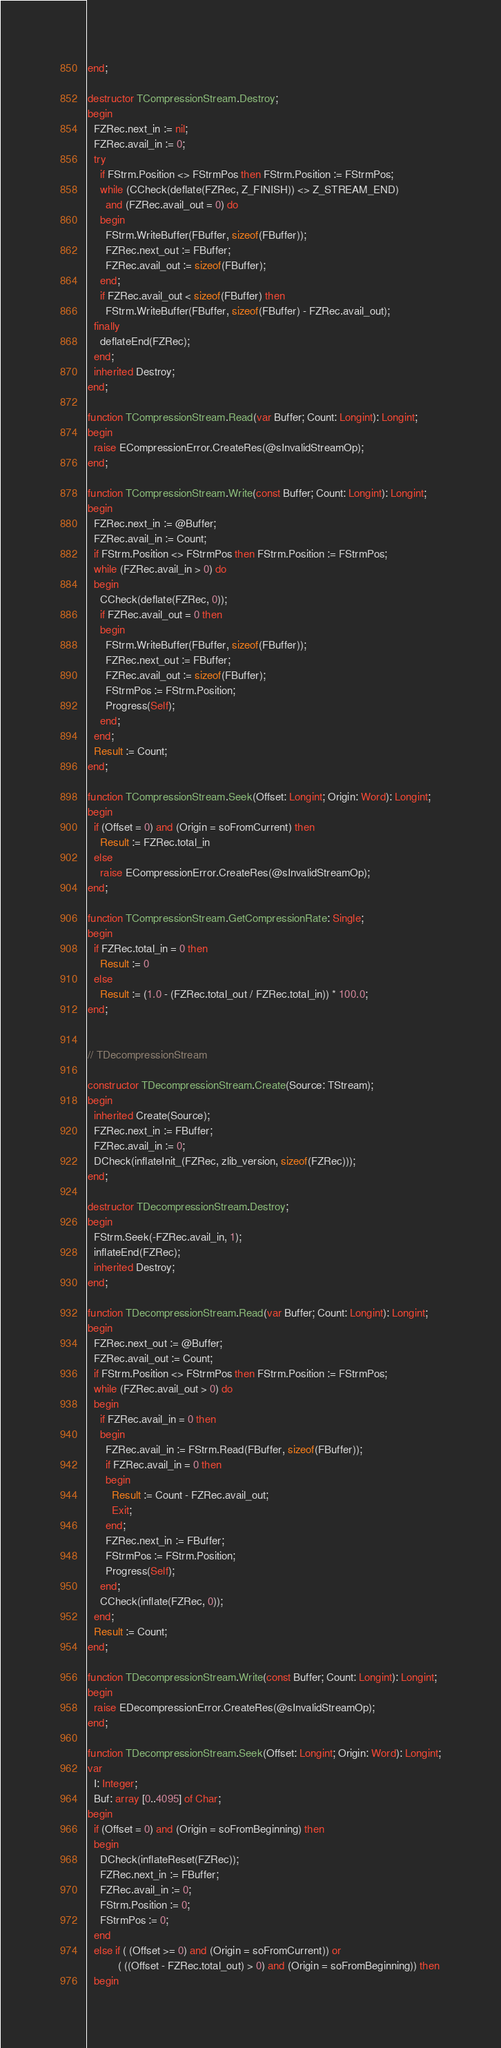Convert code to text. <code><loc_0><loc_0><loc_500><loc_500><_Pascal_>end;

destructor TCompressionStream.Destroy;
begin
  FZRec.next_in := nil;
  FZRec.avail_in := 0;
  try
    if FStrm.Position <> FStrmPos then FStrm.Position := FStrmPos;
    while (CCheck(deflate(FZRec, Z_FINISH)) <> Z_STREAM_END)
      and (FZRec.avail_out = 0) do
    begin
      FStrm.WriteBuffer(FBuffer, sizeof(FBuffer));
      FZRec.next_out := FBuffer;
      FZRec.avail_out := sizeof(FBuffer);
    end;
    if FZRec.avail_out < sizeof(FBuffer) then
      FStrm.WriteBuffer(FBuffer, sizeof(FBuffer) - FZRec.avail_out);
  finally
    deflateEnd(FZRec);
  end;
  inherited Destroy;
end;

function TCompressionStream.Read(var Buffer; Count: Longint): Longint;
begin
  raise ECompressionError.CreateRes(@sInvalidStreamOp);
end;

function TCompressionStream.Write(const Buffer; Count: Longint): Longint;
begin
  FZRec.next_in := @Buffer;
  FZRec.avail_in := Count;
  if FStrm.Position <> FStrmPos then FStrm.Position := FStrmPos;
  while (FZRec.avail_in > 0) do
  begin
    CCheck(deflate(FZRec, 0));
    if FZRec.avail_out = 0 then
    begin
      FStrm.WriteBuffer(FBuffer, sizeof(FBuffer));
      FZRec.next_out := FBuffer;
      FZRec.avail_out := sizeof(FBuffer);
      FStrmPos := FStrm.Position;
      Progress(Self);
    end;
  end;
  Result := Count;
end;

function TCompressionStream.Seek(Offset: Longint; Origin: Word): Longint;
begin
  if (Offset = 0) and (Origin = soFromCurrent) then
    Result := FZRec.total_in
  else
    raise ECompressionError.CreateRes(@sInvalidStreamOp);
end;

function TCompressionStream.GetCompressionRate: Single;
begin
  if FZRec.total_in = 0 then
    Result := 0
  else
    Result := (1.0 - (FZRec.total_out / FZRec.total_in)) * 100.0;
end;


// TDecompressionStream

constructor TDecompressionStream.Create(Source: TStream);
begin
  inherited Create(Source);
  FZRec.next_in := FBuffer;
  FZRec.avail_in := 0;
  DCheck(inflateInit_(FZRec, zlib_version, sizeof(FZRec)));
end;

destructor TDecompressionStream.Destroy;
begin
  FStrm.Seek(-FZRec.avail_in, 1);
  inflateEnd(FZRec);
  inherited Destroy;
end;

function TDecompressionStream.Read(var Buffer; Count: Longint): Longint;
begin
  FZRec.next_out := @Buffer;
  FZRec.avail_out := Count;
  if FStrm.Position <> FStrmPos then FStrm.Position := FStrmPos;
  while (FZRec.avail_out > 0) do
  begin
    if FZRec.avail_in = 0 then
    begin
      FZRec.avail_in := FStrm.Read(FBuffer, sizeof(FBuffer));
      if FZRec.avail_in = 0 then
      begin
        Result := Count - FZRec.avail_out;
        Exit;
      end;
      FZRec.next_in := FBuffer;
      FStrmPos := FStrm.Position;
      Progress(Self);
    end;
    CCheck(inflate(FZRec, 0));
  end;
  Result := Count;
end;

function TDecompressionStream.Write(const Buffer; Count: Longint): Longint;
begin
  raise EDecompressionError.CreateRes(@sInvalidStreamOp);
end;

function TDecompressionStream.Seek(Offset: Longint; Origin: Word): Longint;
var
  I: Integer;
  Buf: array [0..4095] of Char;
begin
  if (Offset = 0) and (Origin = soFromBeginning) then
  begin
    DCheck(inflateReset(FZRec));
    FZRec.next_in := FBuffer;
    FZRec.avail_in := 0;
    FStrm.Position := 0;
    FStrmPos := 0;
  end
  else if ( (Offset >= 0) and (Origin = soFromCurrent)) or
          ( ((Offset - FZRec.total_out) > 0) and (Origin = soFromBeginning)) then
  begin</code> 